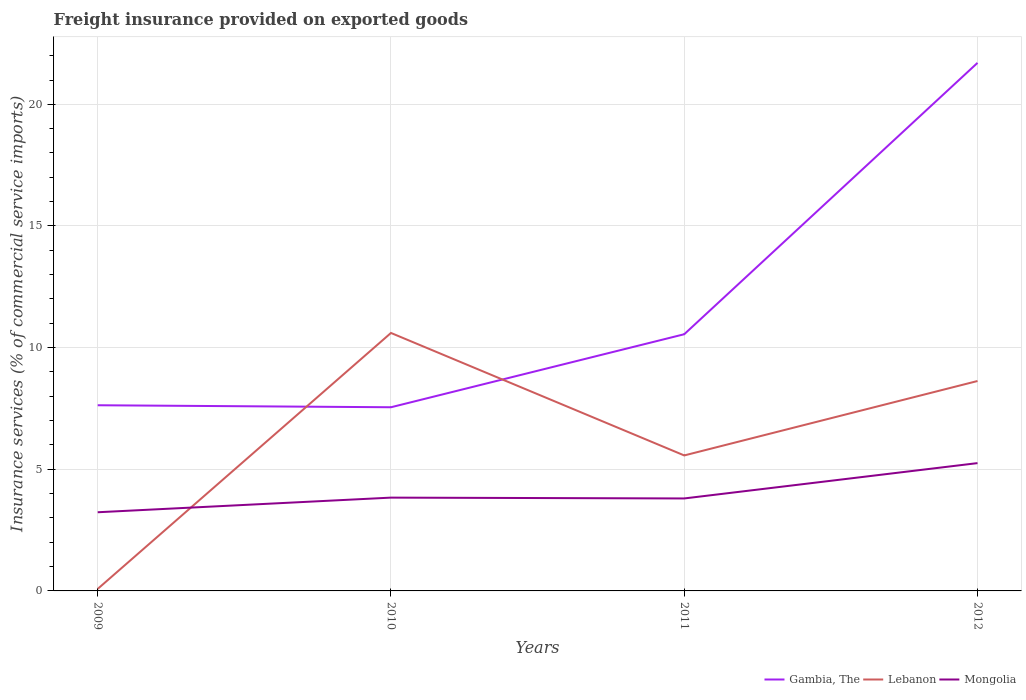Is the number of lines equal to the number of legend labels?
Give a very brief answer. Yes. Across all years, what is the maximum freight insurance provided on exported goods in Mongolia?
Your response must be concise. 3.23. In which year was the freight insurance provided on exported goods in Gambia, The maximum?
Provide a succinct answer. 2010. What is the total freight insurance provided on exported goods in Mongolia in the graph?
Offer a terse response. -1.45. What is the difference between the highest and the second highest freight insurance provided on exported goods in Mongolia?
Make the answer very short. 2.02. Is the freight insurance provided on exported goods in Gambia, The strictly greater than the freight insurance provided on exported goods in Lebanon over the years?
Offer a very short reply. No. How many years are there in the graph?
Your answer should be compact. 4. What is the difference between two consecutive major ticks on the Y-axis?
Offer a terse response. 5. Are the values on the major ticks of Y-axis written in scientific E-notation?
Provide a short and direct response. No. Does the graph contain any zero values?
Offer a very short reply. No. What is the title of the graph?
Keep it short and to the point. Freight insurance provided on exported goods. What is the label or title of the Y-axis?
Your response must be concise. Insurance services (% of commercial service imports). What is the Insurance services (% of commercial service imports) of Gambia, The in 2009?
Keep it short and to the point. 7.63. What is the Insurance services (% of commercial service imports) of Lebanon in 2009?
Your response must be concise. 0.08. What is the Insurance services (% of commercial service imports) in Mongolia in 2009?
Make the answer very short. 3.23. What is the Insurance services (% of commercial service imports) of Gambia, The in 2010?
Your answer should be very brief. 7.55. What is the Insurance services (% of commercial service imports) of Lebanon in 2010?
Offer a terse response. 10.6. What is the Insurance services (% of commercial service imports) in Mongolia in 2010?
Offer a very short reply. 3.83. What is the Insurance services (% of commercial service imports) of Gambia, The in 2011?
Provide a short and direct response. 10.55. What is the Insurance services (% of commercial service imports) of Lebanon in 2011?
Your response must be concise. 5.57. What is the Insurance services (% of commercial service imports) in Mongolia in 2011?
Provide a succinct answer. 3.8. What is the Insurance services (% of commercial service imports) in Gambia, The in 2012?
Provide a short and direct response. 21.7. What is the Insurance services (% of commercial service imports) in Lebanon in 2012?
Your answer should be very brief. 8.63. What is the Insurance services (% of commercial service imports) of Mongolia in 2012?
Your response must be concise. 5.25. Across all years, what is the maximum Insurance services (% of commercial service imports) in Gambia, The?
Offer a very short reply. 21.7. Across all years, what is the maximum Insurance services (% of commercial service imports) of Lebanon?
Offer a terse response. 10.6. Across all years, what is the maximum Insurance services (% of commercial service imports) in Mongolia?
Provide a succinct answer. 5.25. Across all years, what is the minimum Insurance services (% of commercial service imports) in Gambia, The?
Keep it short and to the point. 7.55. Across all years, what is the minimum Insurance services (% of commercial service imports) of Lebanon?
Provide a succinct answer. 0.08. Across all years, what is the minimum Insurance services (% of commercial service imports) of Mongolia?
Provide a short and direct response. 3.23. What is the total Insurance services (% of commercial service imports) of Gambia, The in the graph?
Make the answer very short. 47.44. What is the total Insurance services (% of commercial service imports) in Lebanon in the graph?
Offer a terse response. 24.88. What is the total Insurance services (% of commercial service imports) of Mongolia in the graph?
Keep it short and to the point. 16.12. What is the difference between the Insurance services (% of commercial service imports) of Gambia, The in 2009 and that in 2010?
Provide a succinct answer. 0.08. What is the difference between the Insurance services (% of commercial service imports) of Lebanon in 2009 and that in 2010?
Keep it short and to the point. -10.52. What is the difference between the Insurance services (% of commercial service imports) of Mongolia in 2009 and that in 2010?
Keep it short and to the point. -0.6. What is the difference between the Insurance services (% of commercial service imports) in Gambia, The in 2009 and that in 2011?
Offer a terse response. -2.92. What is the difference between the Insurance services (% of commercial service imports) of Lebanon in 2009 and that in 2011?
Your response must be concise. -5.49. What is the difference between the Insurance services (% of commercial service imports) in Mongolia in 2009 and that in 2011?
Your answer should be compact. -0.57. What is the difference between the Insurance services (% of commercial service imports) in Gambia, The in 2009 and that in 2012?
Provide a short and direct response. -14.07. What is the difference between the Insurance services (% of commercial service imports) in Lebanon in 2009 and that in 2012?
Keep it short and to the point. -8.54. What is the difference between the Insurance services (% of commercial service imports) in Mongolia in 2009 and that in 2012?
Offer a very short reply. -2.02. What is the difference between the Insurance services (% of commercial service imports) of Gambia, The in 2010 and that in 2011?
Provide a succinct answer. -3. What is the difference between the Insurance services (% of commercial service imports) in Lebanon in 2010 and that in 2011?
Give a very brief answer. 5.03. What is the difference between the Insurance services (% of commercial service imports) of Mongolia in 2010 and that in 2011?
Your answer should be compact. 0.03. What is the difference between the Insurance services (% of commercial service imports) in Gambia, The in 2010 and that in 2012?
Give a very brief answer. -14.15. What is the difference between the Insurance services (% of commercial service imports) in Lebanon in 2010 and that in 2012?
Ensure brevity in your answer.  1.98. What is the difference between the Insurance services (% of commercial service imports) in Mongolia in 2010 and that in 2012?
Ensure brevity in your answer.  -1.42. What is the difference between the Insurance services (% of commercial service imports) in Gambia, The in 2011 and that in 2012?
Provide a short and direct response. -11.15. What is the difference between the Insurance services (% of commercial service imports) of Lebanon in 2011 and that in 2012?
Give a very brief answer. -3.06. What is the difference between the Insurance services (% of commercial service imports) of Mongolia in 2011 and that in 2012?
Offer a terse response. -1.45. What is the difference between the Insurance services (% of commercial service imports) in Gambia, The in 2009 and the Insurance services (% of commercial service imports) in Lebanon in 2010?
Provide a short and direct response. -2.97. What is the difference between the Insurance services (% of commercial service imports) in Gambia, The in 2009 and the Insurance services (% of commercial service imports) in Mongolia in 2010?
Make the answer very short. 3.8. What is the difference between the Insurance services (% of commercial service imports) in Lebanon in 2009 and the Insurance services (% of commercial service imports) in Mongolia in 2010?
Your answer should be compact. -3.75. What is the difference between the Insurance services (% of commercial service imports) of Gambia, The in 2009 and the Insurance services (% of commercial service imports) of Lebanon in 2011?
Your answer should be very brief. 2.06. What is the difference between the Insurance services (% of commercial service imports) of Gambia, The in 2009 and the Insurance services (% of commercial service imports) of Mongolia in 2011?
Provide a short and direct response. 3.83. What is the difference between the Insurance services (% of commercial service imports) in Lebanon in 2009 and the Insurance services (% of commercial service imports) in Mongolia in 2011?
Ensure brevity in your answer.  -3.72. What is the difference between the Insurance services (% of commercial service imports) in Gambia, The in 2009 and the Insurance services (% of commercial service imports) in Lebanon in 2012?
Your response must be concise. -1. What is the difference between the Insurance services (% of commercial service imports) in Gambia, The in 2009 and the Insurance services (% of commercial service imports) in Mongolia in 2012?
Offer a terse response. 2.38. What is the difference between the Insurance services (% of commercial service imports) of Lebanon in 2009 and the Insurance services (% of commercial service imports) of Mongolia in 2012?
Your answer should be compact. -5.17. What is the difference between the Insurance services (% of commercial service imports) in Gambia, The in 2010 and the Insurance services (% of commercial service imports) in Lebanon in 2011?
Provide a succinct answer. 1.98. What is the difference between the Insurance services (% of commercial service imports) of Gambia, The in 2010 and the Insurance services (% of commercial service imports) of Mongolia in 2011?
Your response must be concise. 3.75. What is the difference between the Insurance services (% of commercial service imports) in Lebanon in 2010 and the Insurance services (% of commercial service imports) in Mongolia in 2011?
Your answer should be very brief. 6.8. What is the difference between the Insurance services (% of commercial service imports) in Gambia, The in 2010 and the Insurance services (% of commercial service imports) in Lebanon in 2012?
Ensure brevity in your answer.  -1.08. What is the difference between the Insurance services (% of commercial service imports) in Gambia, The in 2010 and the Insurance services (% of commercial service imports) in Mongolia in 2012?
Your response must be concise. 2.3. What is the difference between the Insurance services (% of commercial service imports) in Lebanon in 2010 and the Insurance services (% of commercial service imports) in Mongolia in 2012?
Keep it short and to the point. 5.35. What is the difference between the Insurance services (% of commercial service imports) of Gambia, The in 2011 and the Insurance services (% of commercial service imports) of Lebanon in 2012?
Provide a short and direct response. 1.92. What is the difference between the Insurance services (% of commercial service imports) in Gambia, The in 2011 and the Insurance services (% of commercial service imports) in Mongolia in 2012?
Give a very brief answer. 5.3. What is the difference between the Insurance services (% of commercial service imports) in Lebanon in 2011 and the Insurance services (% of commercial service imports) in Mongolia in 2012?
Your answer should be compact. 0.32. What is the average Insurance services (% of commercial service imports) in Gambia, The per year?
Offer a very short reply. 11.86. What is the average Insurance services (% of commercial service imports) in Lebanon per year?
Give a very brief answer. 6.22. What is the average Insurance services (% of commercial service imports) in Mongolia per year?
Your response must be concise. 4.03. In the year 2009, what is the difference between the Insurance services (% of commercial service imports) of Gambia, The and Insurance services (% of commercial service imports) of Lebanon?
Offer a very short reply. 7.55. In the year 2009, what is the difference between the Insurance services (% of commercial service imports) of Gambia, The and Insurance services (% of commercial service imports) of Mongolia?
Offer a terse response. 4.4. In the year 2009, what is the difference between the Insurance services (% of commercial service imports) of Lebanon and Insurance services (% of commercial service imports) of Mongolia?
Keep it short and to the point. -3.15. In the year 2010, what is the difference between the Insurance services (% of commercial service imports) of Gambia, The and Insurance services (% of commercial service imports) of Lebanon?
Keep it short and to the point. -3.05. In the year 2010, what is the difference between the Insurance services (% of commercial service imports) of Gambia, The and Insurance services (% of commercial service imports) of Mongolia?
Your answer should be compact. 3.71. In the year 2010, what is the difference between the Insurance services (% of commercial service imports) in Lebanon and Insurance services (% of commercial service imports) in Mongolia?
Your answer should be very brief. 6.77. In the year 2011, what is the difference between the Insurance services (% of commercial service imports) in Gambia, The and Insurance services (% of commercial service imports) in Lebanon?
Offer a terse response. 4.98. In the year 2011, what is the difference between the Insurance services (% of commercial service imports) in Gambia, The and Insurance services (% of commercial service imports) in Mongolia?
Keep it short and to the point. 6.75. In the year 2011, what is the difference between the Insurance services (% of commercial service imports) of Lebanon and Insurance services (% of commercial service imports) of Mongolia?
Provide a succinct answer. 1.77. In the year 2012, what is the difference between the Insurance services (% of commercial service imports) in Gambia, The and Insurance services (% of commercial service imports) in Lebanon?
Provide a succinct answer. 13.08. In the year 2012, what is the difference between the Insurance services (% of commercial service imports) in Gambia, The and Insurance services (% of commercial service imports) in Mongolia?
Your answer should be very brief. 16.45. In the year 2012, what is the difference between the Insurance services (% of commercial service imports) in Lebanon and Insurance services (% of commercial service imports) in Mongolia?
Give a very brief answer. 3.37. What is the ratio of the Insurance services (% of commercial service imports) in Gambia, The in 2009 to that in 2010?
Offer a terse response. 1.01. What is the ratio of the Insurance services (% of commercial service imports) of Lebanon in 2009 to that in 2010?
Your answer should be very brief. 0.01. What is the ratio of the Insurance services (% of commercial service imports) in Mongolia in 2009 to that in 2010?
Offer a terse response. 0.84. What is the ratio of the Insurance services (% of commercial service imports) in Gambia, The in 2009 to that in 2011?
Offer a very short reply. 0.72. What is the ratio of the Insurance services (% of commercial service imports) in Lebanon in 2009 to that in 2011?
Ensure brevity in your answer.  0.01. What is the ratio of the Insurance services (% of commercial service imports) in Mongolia in 2009 to that in 2011?
Keep it short and to the point. 0.85. What is the ratio of the Insurance services (% of commercial service imports) in Gambia, The in 2009 to that in 2012?
Keep it short and to the point. 0.35. What is the ratio of the Insurance services (% of commercial service imports) of Lebanon in 2009 to that in 2012?
Offer a terse response. 0.01. What is the ratio of the Insurance services (% of commercial service imports) of Mongolia in 2009 to that in 2012?
Your answer should be compact. 0.62. What is the ratio of the Insurance services (% of commercial service imports) of Gambia, The in 2010 to that in 2011?
Give a very brief answer. 0.72. What is the ratio of the Insurance services (% of commercial service imports) in Lebanon in 2010 to that in 2011?
Your response must be concise. 1.9. What is the ratio of the Insurance services (% of commercial service imports) of Gambia, The in 2010 to that in 2012?
Offer a very short reply. 0.35. What is the ratio of the Insurance services (% of commercial service imports) of Lebanon in 2010 to that in 2012?
Provide a short and direct response. 1.23. What is the ratio of the Insurance services (% of commercial service imports) in Mongolia in 2010 to that in 2012?
Ensure brevity in your answer.  0.73. What is the ratio of the Insurance services (% of commercial service imports) of Gambia, The in 2011 to that in 2012?
Ensure brevity in your answer.  0.49. What is the ratio of the Insurance services (% of commercial service imports) in Lebanon in 2011 to that in 2012?
Provide a short and direct response. 0.65. What is the ratio of the Insurance services (% of commercial service imports) in Mongolia in 2011 to that in 2012?
Offer a very short reply. 0.72. What is the difference between the highest and the second highest Insurance services (% of commercial service imports) of Gambia, The?
Offer a terse response. 11.15. What is the difference between the highest and the second highest Insurance services (% of commercial service imports) of Lebanon?
Ensure brevity in your answer.  1.98. What is the difference between the highest and the second highest Insurance services (% of commercial service imports) in Mongolia?
Your answer should be very brief. 1.42. What is the difference between the highest and the lowest Insurance services (% of commercial service imports) in Gambia, The?
Keep it short and to the point. 14.15. What is the difference between the highest and the lowest Insurance services (% of commercial service imports) of Lebanon?
Provide a short and direct response. 10.52. What is the difference between the highest and the lowest Insurance services (% of commercial service imports) in Mongolia?
Offer a very short reply. 2.02. 